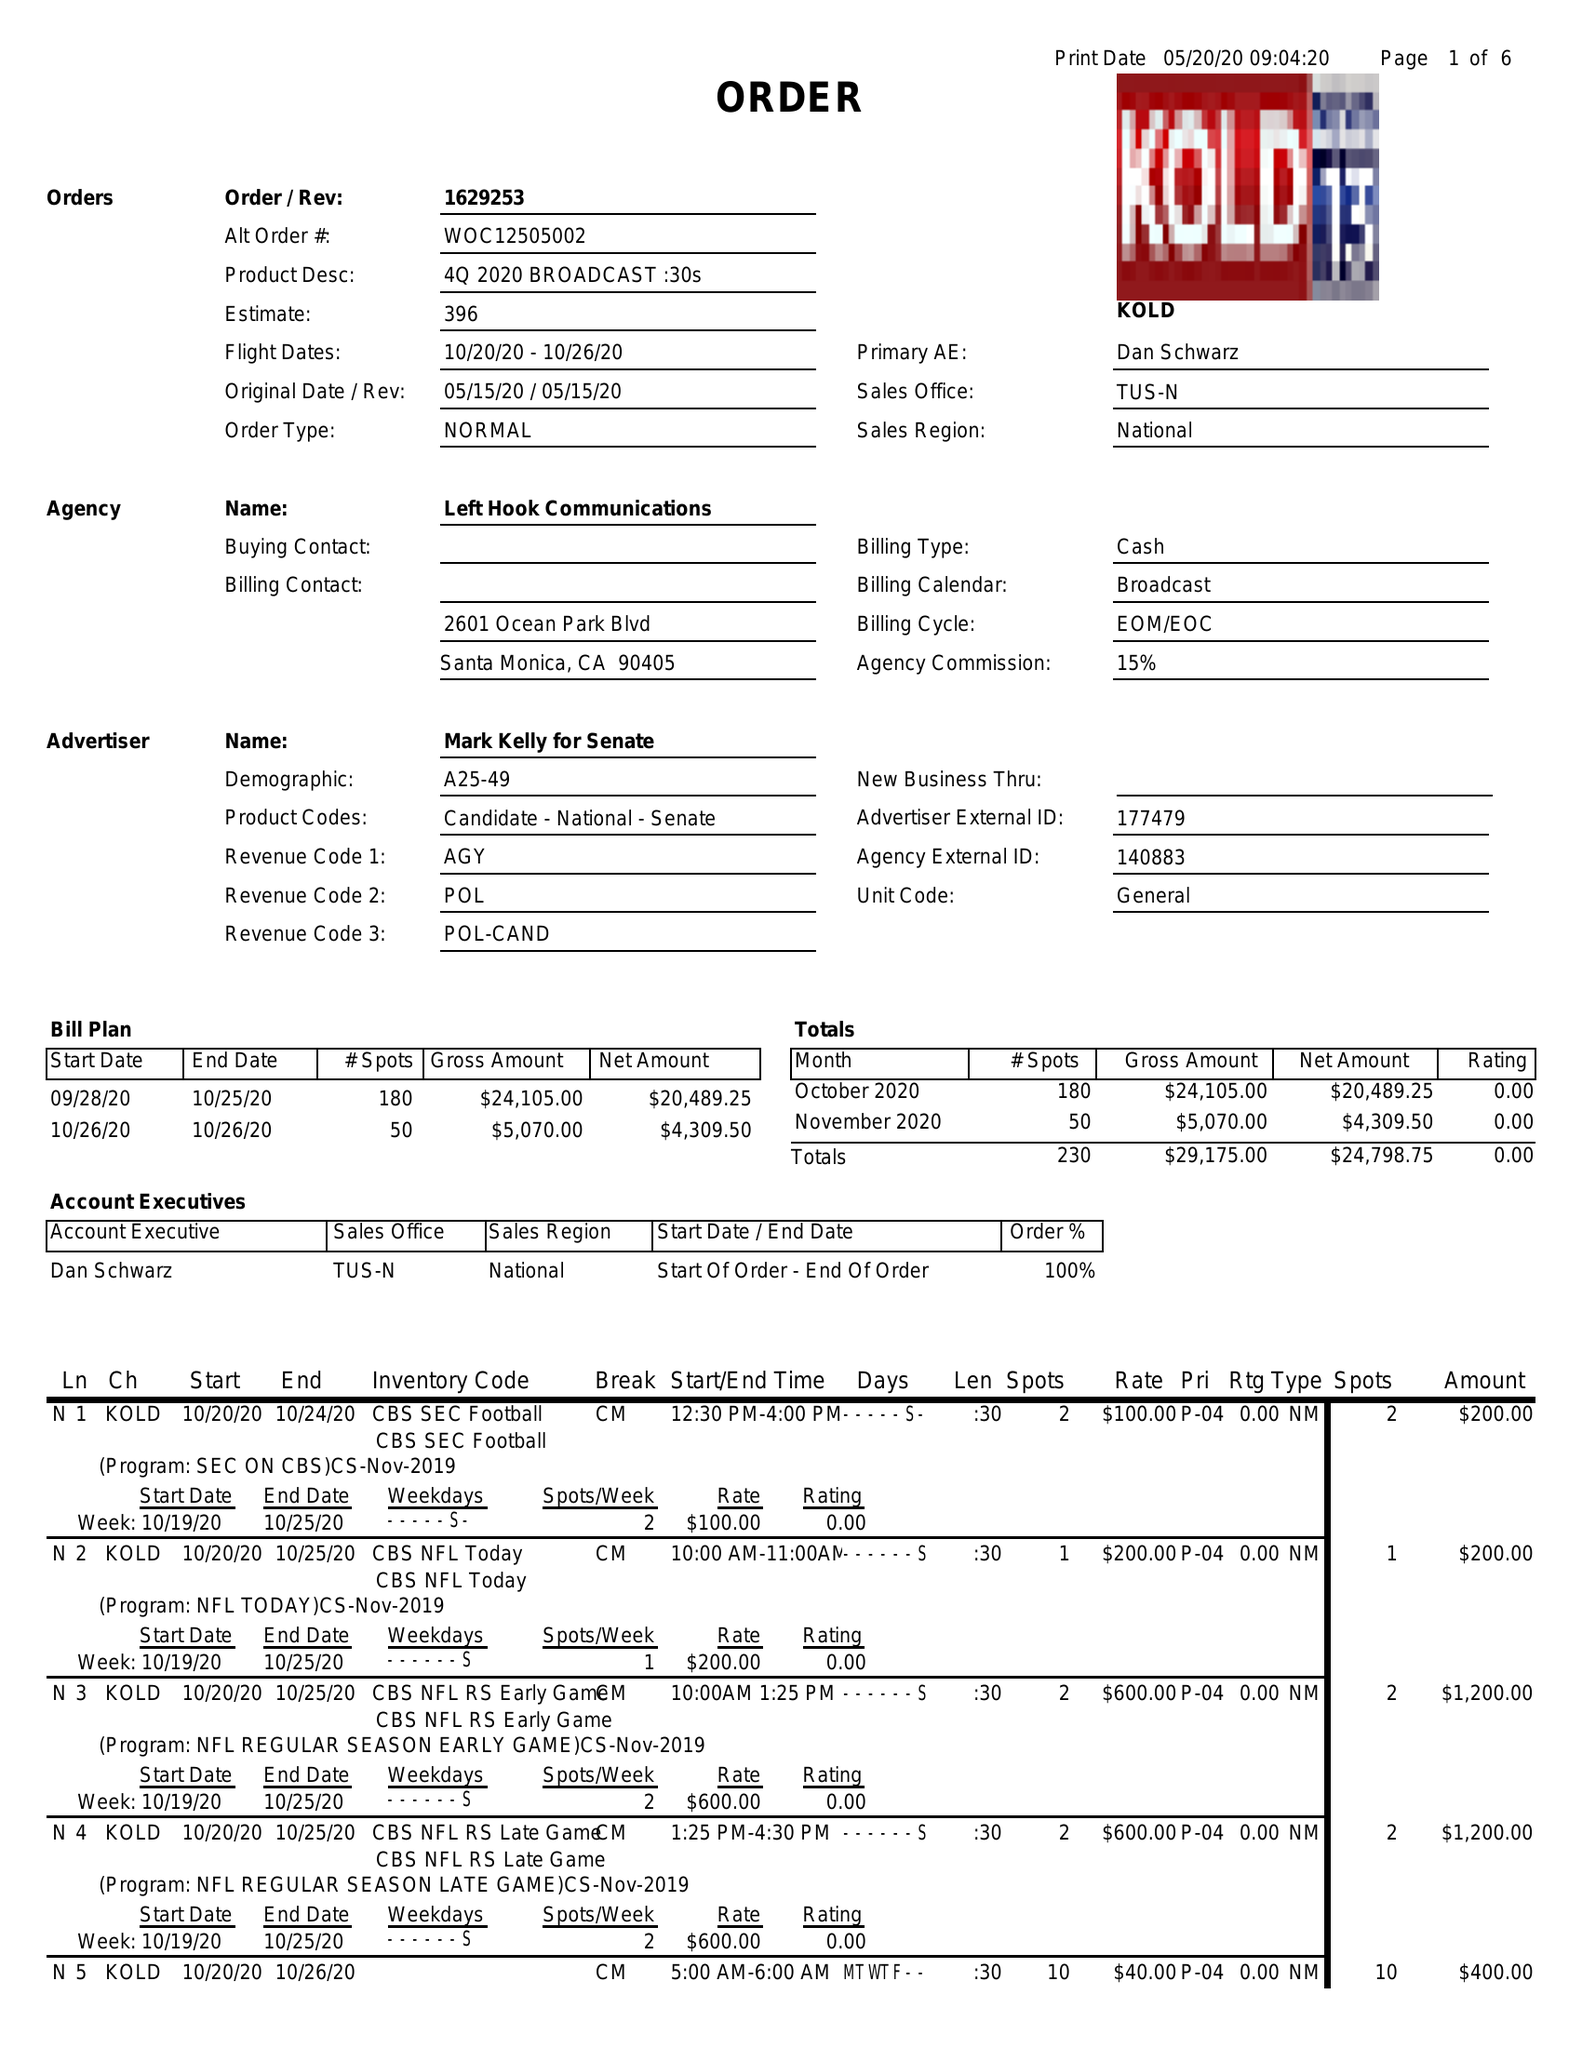What is the value for the flight_from?
Answer the question using a single word or phrase. 10/20/20 